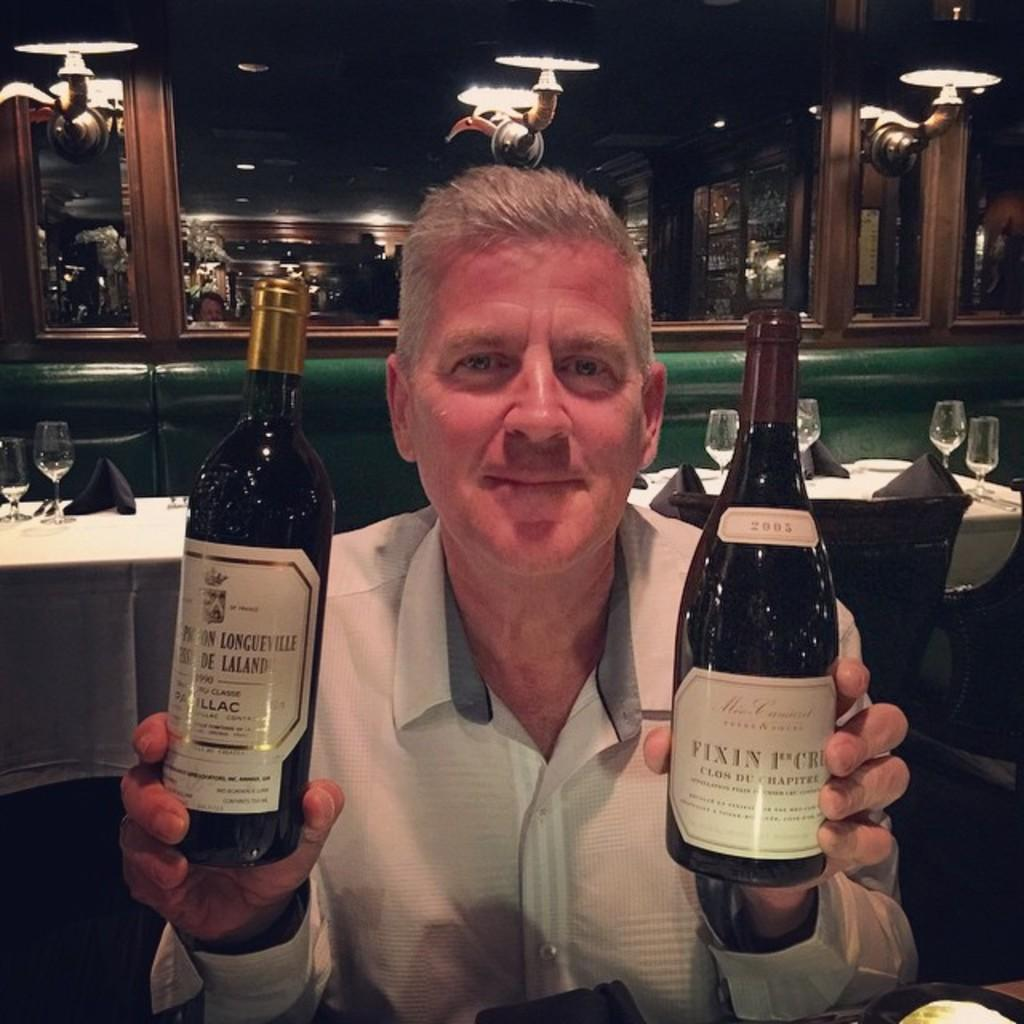<image>
Relay a brief, clear account of the picture shown. A man is holding up two bottles and one is labeled with the year 2003. 